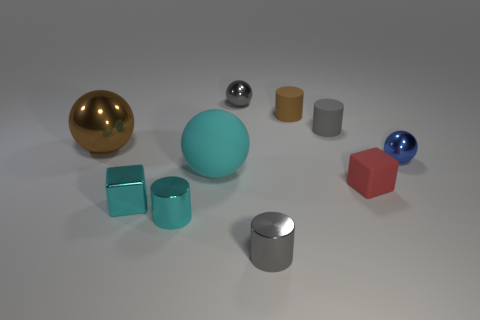There is a big sphere in front of the blue sphere; is it the same color as the tiny metallic cube?
Your response must be concise. Yes. What number of things are either rubber objects or big things in front of the large brown metal object?
Ensure brevity in your answer.  4. There is a small rubber object on the right side of the small gray rubber thing; is its shape the same as the cyan metallic object that is behind the small cyan cylinder?
Your answer should be very brief. Yes. Is there anything else of the same color as the tiny shiny cube?
Make the answer very short. Yes. What is the shape of the red thing that is the same material as the tiny brown cylinder?
Provide a short and direct response. Cube. What material is the tiny cylinder that is to the left of the gray rubber object and behind the red matte block?
Provide a short and direct response. Rubber. Do the metallic block and the matte sphere have the same color?
Make the answer very short. Yes. There is a metal thing that is the same color as the metal cube; what shape is it?
Give a very brief answer. Cylinder. How many other cyan objects have the same shape as the large rubber thing?
Offer a terse response. 0. The cyan object that is made of the same material as the small red block is what size?
Offer a terse response. Large. 